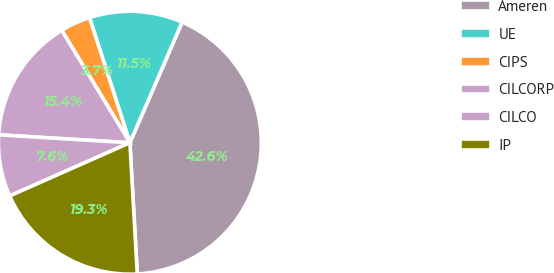Convert chart to OTSL. <chart><loc_0><loc_0><loc_500><loc_500><pie_chart><fcel>Ameren<fcel>UE<fcel>CIPS<fcel>CILCORP<fcel>CILCO<fcel>IP<nl><fcel>42.59%<fcel>11.48%<fcel>3.7%<fcel>15.37%<fcel>7.59%<fcel>19.26%<nl></chart> 